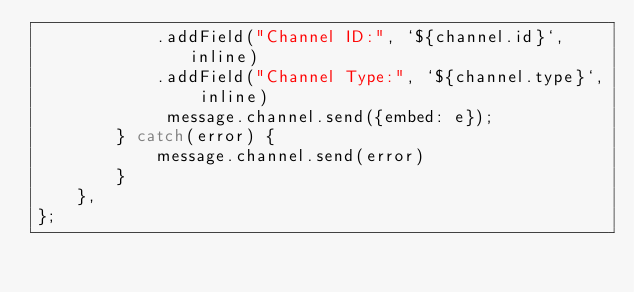<code> <loc_0><loc_0><loc_500><loc_500><_JavaScript_>            .addField("Channel ID:", `${channel.id}`, inline)
            .addField("Channel Type:", `${channel.type}`, inline)
             message.channel.send({embed: e});
        } catch(error) {
            message.channel.send(error)
        }
    },
};</code> 